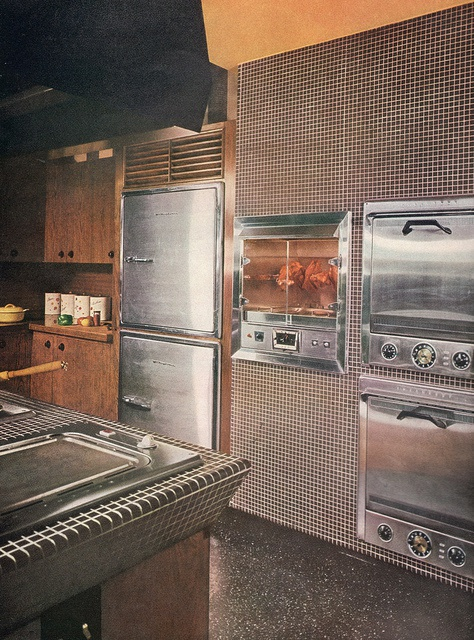Describe the objects in this image and their specific colors. I can see oven in black, gray, and darkgray tones, refrigerator in black, darkgray, lightgray, and gray tones, oven in black, gray, brown, darkgray, and lightgray tones, cup in black, tan, beige, and maroon tones, and bowl in black, tan, brown, and gray tones in this image. 